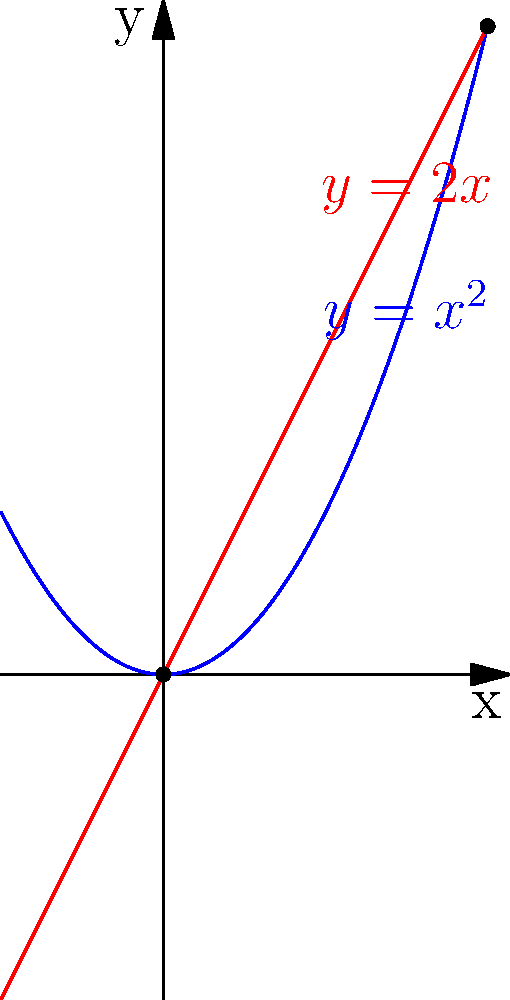During your study abroad in the US, you're tasked with calculating the area between two curves for a project on Paraguayan agricultural land use. The curves represent different growth models for crops. Find the area enclosed between the curves $y=x^2$ and $y=2x$ in the first quadrant. To find the area between the two curves, we'll follow these steps:

1) First, we need to find the points of intersection. Set the equations equal:
   $x^2 = 2x$
   $x^2 - 2x = 0$
   $x(x - 2) = 0$
   $x = 0$ or $x = 2$

2) The curves intersect at (0,0) and (2,4).

3) To find the area, we'll integrate the difference between the upper and lower functions from x = 0 to x = 2:

   $A = \int_0^2 (2x - x^2) dx$

4) Expand the integral:
   $A = \int_0^2 (2x - x^2) dx = [x^2 - \frac{1}{3}x^3]_0^2$

5) Evaluate the integral:
   $A = (2^2 - \frac{1}{3}2^3) - (0^2 - \frac{1}{3}0^3)$
   $A = (4 - \frac{8}{3}) - 0 = \frac{4}{3}$

Therefore, the area between the curves is $\frac{4}{3}$ square units.
Answer: $\frac{4}{3}$ square units 